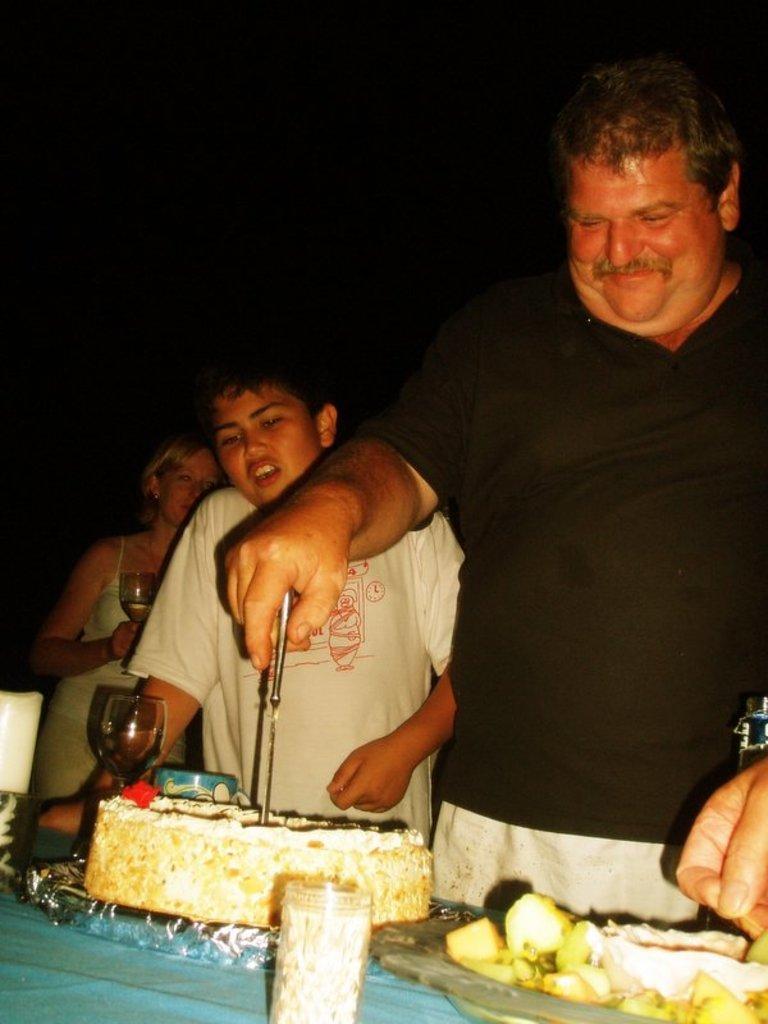How would you summarize this image in a sentence or two? In the right side a man is standing and cutting the cake, he wore a t-shirt. Beside him there is a boy standing, he wore a t-shirt. In the left there is a woman holding a wine glass. 